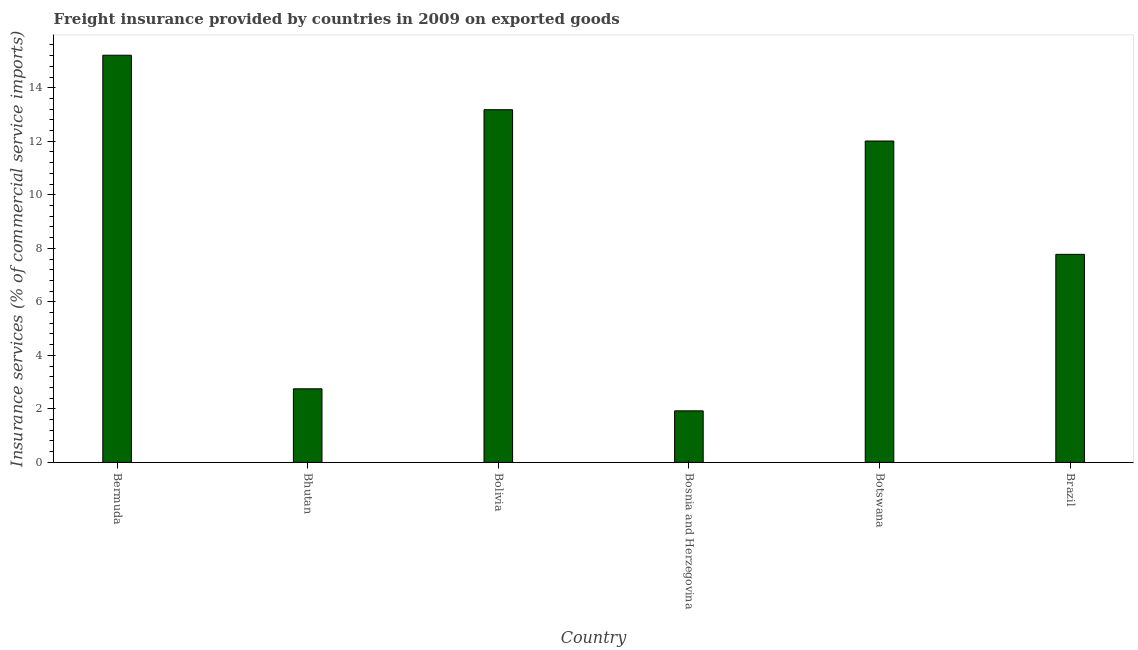What is the title of the graph?
Make the answer very short. Freight insurance provided by countries in 2009 on exported goods . What is the label or title of the X-axis?
Your answer should be compact. Country. What is the label or title of the Y-axis?
Give a very brief answer. Insurance services (% of commercial service imports). What is the freight insurance in Botswana?
Keep it short and to the point. 12.01. Across all countries, what is the maximum freight insurance?
Ensure brevity in your answer.  15.22. Across all countries, what is the minimum freight insurance?
Your response must be concise. 1.93. In which country was the freight insurance maximum?
Your answer should be very brief. Bermuda. In which country was the freight insurance minimum?
Make the answer very short. Bosnia and Herzegovina. What is the sum of the freight insurance?
Provide a succinct answer. 52.86. What is the difference between the freight insurance in Botswana and Brazil?
Ensure brevity in your answer.  4.24. What is the average freight insurance per country?
Offer a very short reply. 8.81. What is the median freight insurance?
Your answer should be very brief. 9.89. What is the ratio of the freight insurance in Bhutan to that in Botswana?
Offer a very short reply. 0.23. Is the freight insurance in Bermuda less than that in Bhutan?
Your answer should be very brief. No. Is the difference between the freight insurance in Bermuda and Botswana greater than the difference between any two countries?
Your answer should be very brief. No. What is the difference between the highest and the second highest freight insurance?
Give a very brief answer. 2.04. What is the difference between the highest and the lowest freight insurance?
Ensure brevity in your answer.  13.29. In how many countries, is the freight insurance greater than the average freight insurance taken over all countries?
Your answer should be very brief. 3. How many countries are there in the graph?
Keep it short and to the point. 6. What is the difference between two consecutive major ticks on the Y-axis?
Make the answer very short. 2. What is the Insurance services (% of commercial service imports) of Bermuda?
Give a very brief answer. 15.22. What is the Insurance services (% of commercial service imports) in Bhutan?
Your response must be concise. 2.75. What is the Insurance services (% of commercial service imports) of Bolivia?
Provide a succinct answer. 13.18. What is the Insurance services (% of commercial service imports) in Bosnia and Herzegovina?
Give a very brief answer. 1.93. What is the Insurance services (% of commercial service imports) of Botswana?
Your response must be concise. 12.01. What is the Insurance services (% of commercial service imports) of Brazil?
Make the answer very short. 7.77. What is the difference between the Insurance services (% of commercial service imports) in Bermuda and Bhutan?
Provide a short and direct response. 12.47. What is the difference between the Insurance services (% of commercial service imports) in Bermuda and Bolivia?
Give a very brief answer. 2.04. What is the difference between the Insurance services (% of commercial service imports) in Bermuda and Bosnia and Herzegovina?
Your response must be concise. 13.29. What is the difference between the Insurance services (% of commercial service imports) in Bermuda and Botswana?
Provide a short and direct response. 3.21. What is the difference between the Insurance services (% of commercial service imports) in Bermuda and Brazil?
Provide a short and direct response. 7.44. What is the difference between the Insurance services (% of commercial service imports) in Bhutan and Bolivia?
Ensure brevity in your answer.  -10.43. What is the difference between the Insurance services (% of commercial service imports) in Bhutan and Bosnia and Herzegovina?
Your response must be concise. 0.82. What is the difference between the Insurance services (% of commercial service imports) in Bhutan and Botswana?
Give a very brief answer. -9.26. What is the difference between the Insurance services (% of commercial service imports) in Bhutan and Brazil?
Your answer should be very brief. -5.02. What is the difference between the Insurance services (% of commercial service imports) in Bolivia and Bosnia and Herzegovina?
Ensure brevity in your answer.  11.25. What is the difference between the Insurance services (% of commercial service imports) in Bolivia and Botswana?
Your answer should be very brief. 1.17. What is the difference between the Insurance services (% of commercial service imports) in Bolivia and Brazil?
Offer a terse response. 5.4. What is the difference between the Insurance services (% of commercial service imports) in Bosnia and Herzegovina and Botswana?
Provide a short and direct response. -10.08. What is the difference between the Insurance services (% of commercial service imports) in Bosnia and Herzegovina and Brazil?
Your response must be concise. -5.85. What is the difference between the Insurance services (% of commercial service imports) in Botswana and Brazil?
Offer a very short reply. 4.24. What is the ratio of the Insurance services (% of commercial service imports) in Bermuda to that in Bhutan?
Provide a short and direct response. 5.53. What is the ratio of the Insurance services (% of commercial service imports) in Bermuda to that in Bolivia?
Offer a terse response. 1.15. What is the ratio of the Insurance services (% of commercial service imports) in Bermuda to that in Bosnia and Herzegovina?
Make the answer very short. 7.9. What is the ratio of the Insurance services (% of commercial service imports) in Bermuda to that in Botswana?
Provide a short and direct response. 1.27. What is the ratio of the Insurance services (% of commercial service imports) in Bermuda to that in Brazil?
Make the answer very short. 1.96. What is the ratio of the Insurance services (% of commercial service imports) in Bhutan to that in Bolivia?
Give a very brief answer. 0.21. What is the ratio of the Insurance services (% of commercial service imports) in Bhutan to that in Bosnia and Herzegovina?
Offer a terse response. 1.43. What is the ratio of the Insurance services (% of commercial service imports) in Bhutan to that in Botswana?
Make the answer very short. 0.23. What is the ratio of the Insurance services (% of commercial service imports) in Bhutan to that in Brazil?
Keep it short and to the point. 0.35. What is the ratio of the Insurance services (% of commercial service imports) in Bolivia to that in Bosnia and Herzegovina?
Ensure brevity in your answer.  6.84. What is the ratio of the Insurance services (% of commercial service imports) in Bolivia to that in Botswana?
Your answer should be very brief. 1.1. What is the ratio of the Insurance services (% of commercial service imports) in Bolivia to that in Brazil?
Your answer should be very brief. 1.7. What is the ratio of the Insurance services (% of commercial service imports) in Bosnia and Herzegovina to that in Botswana?
Provide a succinct answer. 0.16. What is the ratio of the Insurance services (% of commercial service imports) in Bosnia and Herzegovina to that in Brazil?
Your response must be concise. 0.25. What is the ratio of the Insurance services (% of commercial service imports) in Botswana to that in Brazil?
Your answer should be very brief. 1.54. 